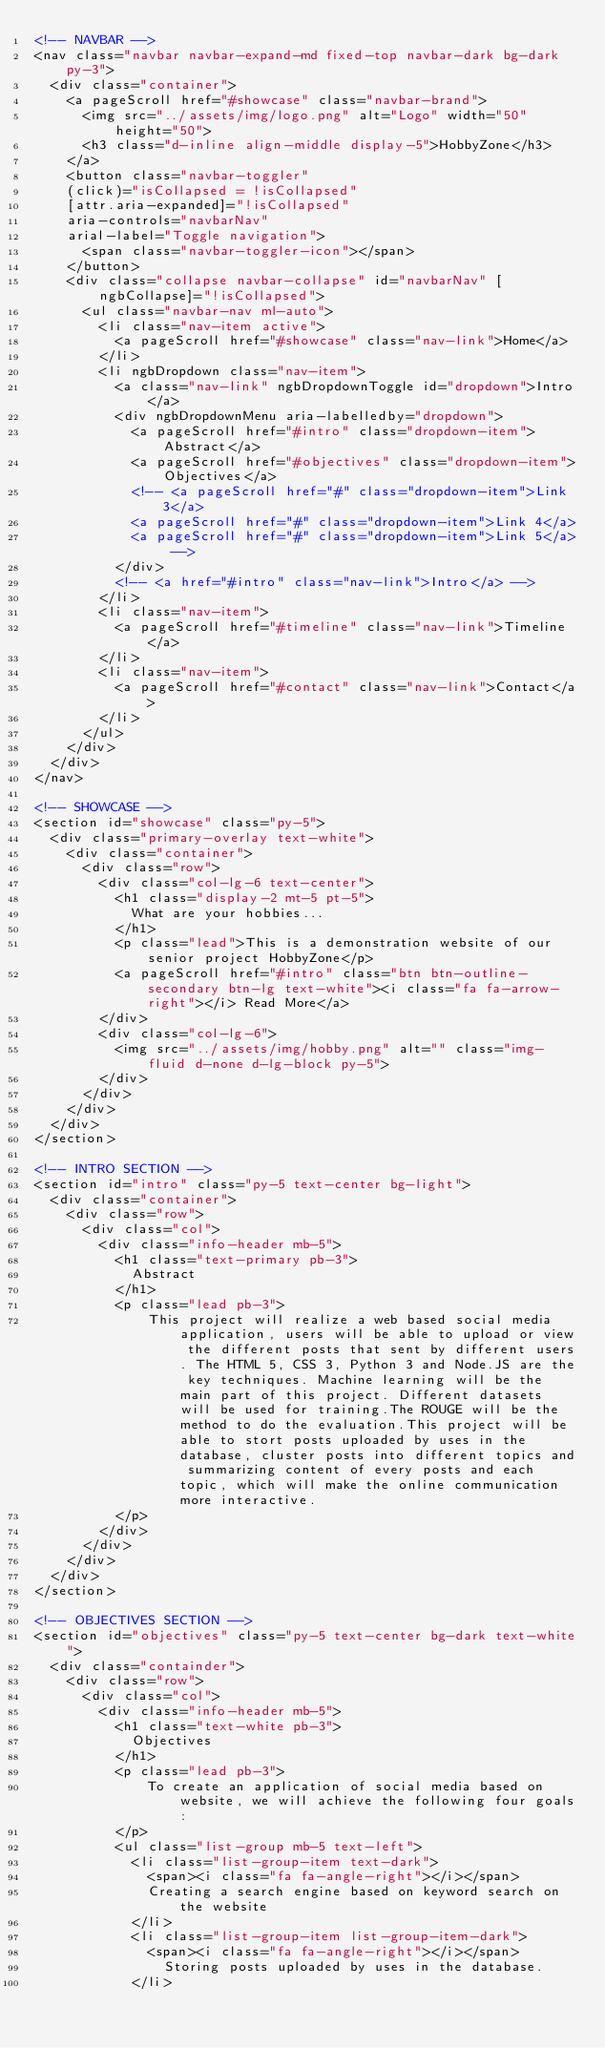<code> <loc_0><loc_0><loc_500><loc_500><_HTML_><!-- NAVBAR -->
<nav class="navbar navbar-expand-md fixed-top navbar-dark bg-dark py-3">
  <div class="container">
    <a pageScroll href="#showcase" class="navbar-brand">
      <img src="../assets/img/logo.png" alt="Logo" width="50" height="50">
      <h3 class="d-inline align-middle display-5">HobbyZone</h3>
    </a>
    <button class="navbar-toggler" 
    (click)="isCollapsed = !isCollapsed" 
    [attr.aria-expanded]="!isCollapsed"
    aria-controls="navbarNav"
    arial-label="Toggle navigation">
      <span class="navbar-toggler-icon"></span>
    </button>
    <div class="collapse navbar-collapse" id="navbarNav" [ngbCollapse]="!isCollapsed">
      <ul class="navbar-nav ml-auto">
        <li class="nav-item active">
          <a pageScroll href="#showcase" class="nav-link">Home</a>
        </li>
        <li ngbDropdown class="nav-item">
          <a class="nav-link" ngbDropdownToggle id="dropdown">Intro</a>
          <div ngbDropdownMenu aria-labelledby="dropdown">
            <a pageScroll href="#intro" class="dropdown-item">Abstract</a>
            <a pageScroll href="#objectives" class="dropdown-item">Objectives</a>
            <!-- <a pageScroll href="#" class="dropdown-item">Link 3</a>
            <a pageScroll href="#" class="dropdown-item">Link 4</a>
            <a pageScroll href="#" class="dropdown-item">Link 5</a> -->
          </div>
          <!-- <a href="#intro" class="nav-link">Intro</a> -->
        </li>
        <li class="nav-item">
          <a pageScroll href="#timeline" class="nav-link">Timeline</a>
        </li>
        <li class="nav-item">
          <a pageScroll href="#contact" class="nav-link">Contact</a>
        </li>
      </ul>
    </div>
  </div>
</nav>

<!-- SHOWCASE -->
<section id="showcase" class="py-5">
  <div class="primary-overlay text-white">
    <div class="container">
      <div class="row">
        <div class="col-lg-6 text-center">
          <h1 class="display-2 mt-5 pt-5">
            What are your hobbies...
          </h1>
          <p class="lead">This is a demonstration website of our senior project HobbyZone</p>
          <a pageScroll href="#intro" class="btn btn-outline-secondary btn-lg text-white"><i class="fa fa-arrow-right"></i> Read More</a>
        </div>
        <div class="col-lg-6">
          <img src="../assets/img/hobby.png" alt="" class="img-fluid d-none d-lg-block py-5">
        </div>
      </div>
    </div>
  </div>
</section>

<!-- INTRO SECTION -->
<section id="intro" class="py-5 text-center bg-light">
  <div class="container">
    <div class="row">
      <div class="col">
        <div class="info-header mb-5">
          <h1 class="text-primary pb-3">
            Abstract
          </h1>
          <p class="lead pb-3">
              This project will realize a web based social media application, users will be able to upload or view the different posts that sent by different users. The HTML 5, CSS 3, Python 3 and Node.JS are the key techniques. Machine learning will be the main part of this project. Different datasets will be used for training.The ROUGE will be the method to do the evaluation.This project will be able to stort posts uploaded by uses in the database, cluster posts into different topics and summarizing content of every posts and each topic, which will make the online communication more interactive.
          </p>
        </div>
      </div>
    </div>
  </div>
</section>

<!-- OBJECTIVES SECTION -->
<section id="objectives" class="py-5 text-center bg-dark text-white">
  <div class="containder">
    <div class="row">
      <div class="col">
        <div class="info-header mb-5">
          <h1 class="text-white pb-3">
            Objectives
          </h1>
          <p class="lead pb-3">
              To create an application of social media based on website, we will achieve the following four goals:
          </p>
          <ul class="list-group mb-5 text-left">
            <li class="list-group-item text-dark">
              <span><i class="fa fa-angle-right"></i></span>
              Creating a search engine based on keyword search on the website
            </li>
            <li class="list-group-item list-group-item-dark">
              <span><i class="fa fa-angle-right"></i></span>
                Storing posts uploaded by uses in the database.
            </li></code> 